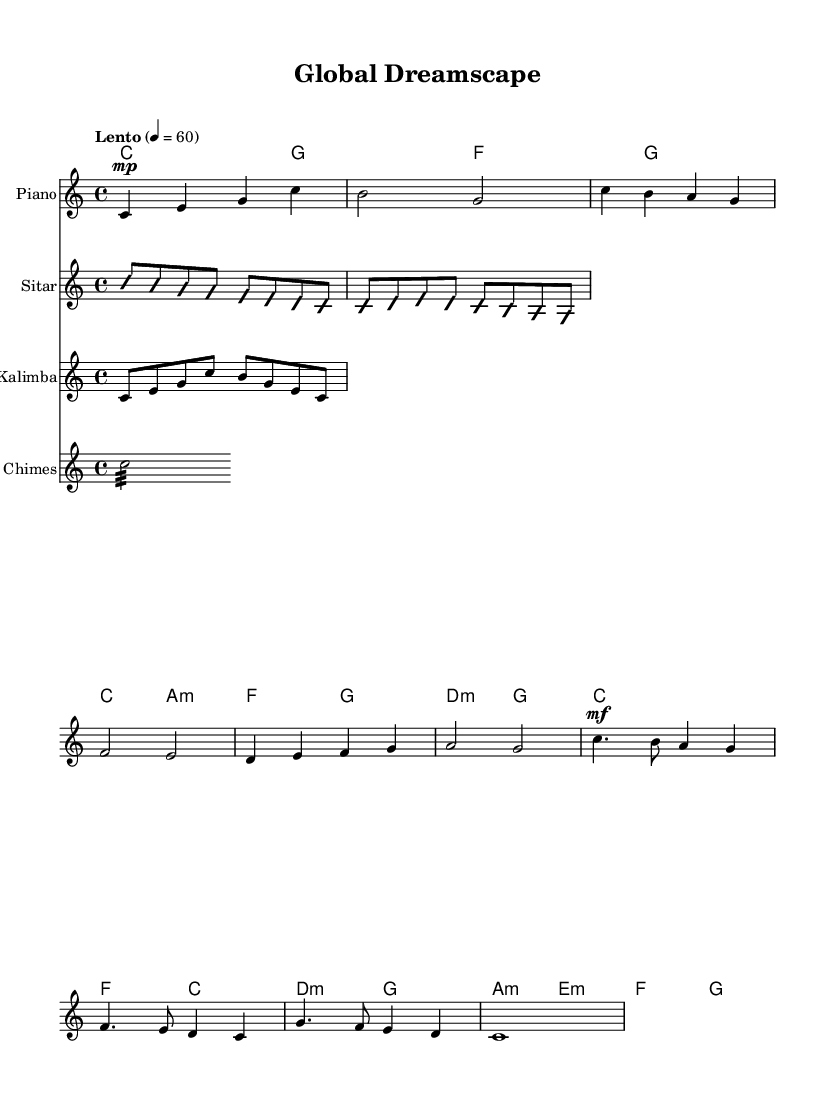What is the key signature of this music? The key signature is indicated at the beginning of the score, which shows no sharps or flats. This confirms that it is in C major.
Answer: C major What is the time signature of this music? The time signature appears at the beginning of the score as 4/4, meaning there are four beats in each measure and the quarter note receives one beat.
Answer: 4/4 What is the tempo marking of this piece? The tempo marking appears at the start as "Lento," which indicates a slow tempo. The metronome marking of 60 beats per minute supports this.
Answer: Lento Which instruments are featured in the score? By looking at the instrument names labeled above the staves, we can see that the featured instruments are Piano, Sitar, Kalimba, and Wind Chimes.
Answer: Piano, Sitar, Kalimba, Wind Chimes How many measures are in the chorus section? The chorus section is identified by the dynamic marking "mf" and consists of four measures visible in that section of the score. Counting these measures gives the answer.
Answer: 4 What type of harmony is used in the verse section? The harmony in the verse section can be found in the chord names below the melody, which shows a mix of major and minor chords, indicating a tonal diversity typical in world music.
Answer: Major and minor chords What is the dynamic marking for the chorus section? The dynamic marking is indicated prominently before the chorus begins, which specifies "mf," signaling a moderately loud volume compared to the previous sections.
Answer: mf 